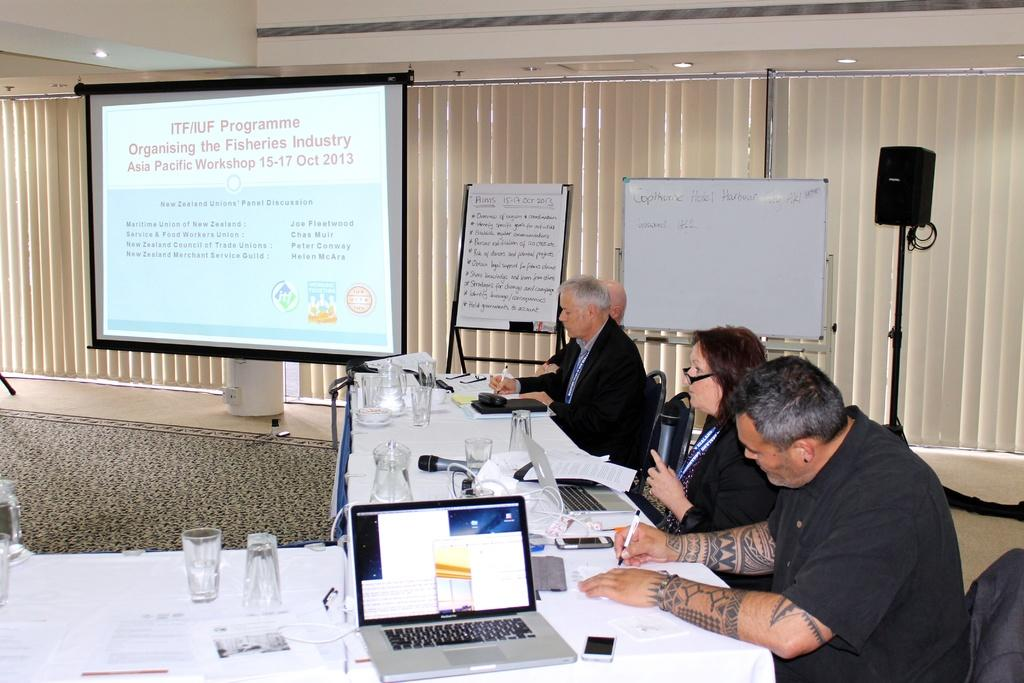<image>
Present a compact description of the photo's key features. A projector screen has a presentation for ITF/IUF Programme on display 